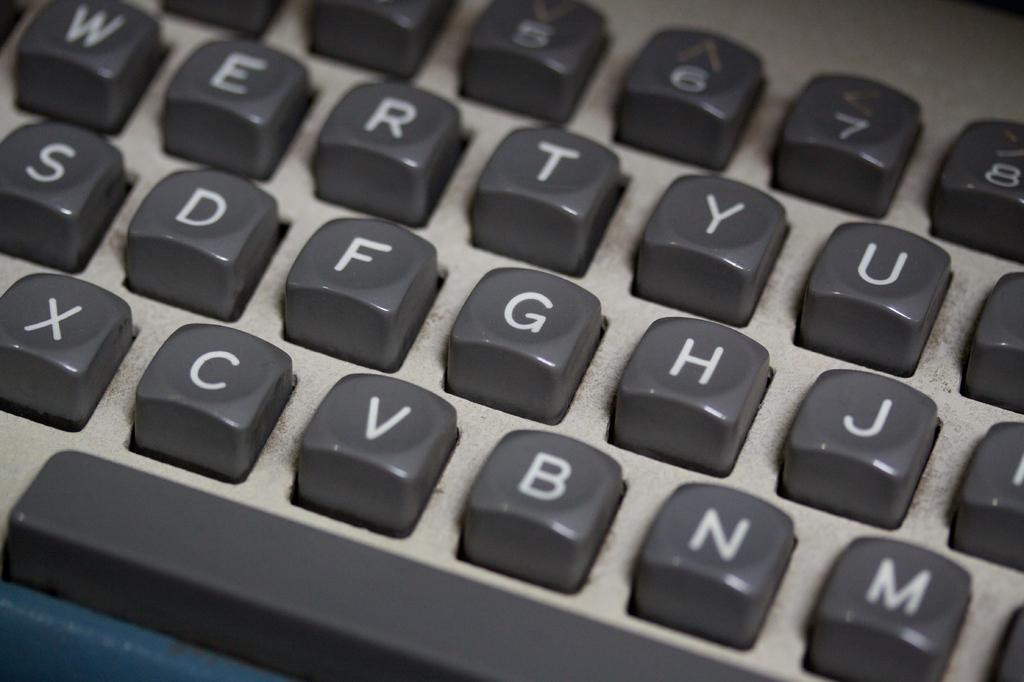<image>
Render a clear and concise summary of the photo. A keypad has the letter G right between the F and H. 